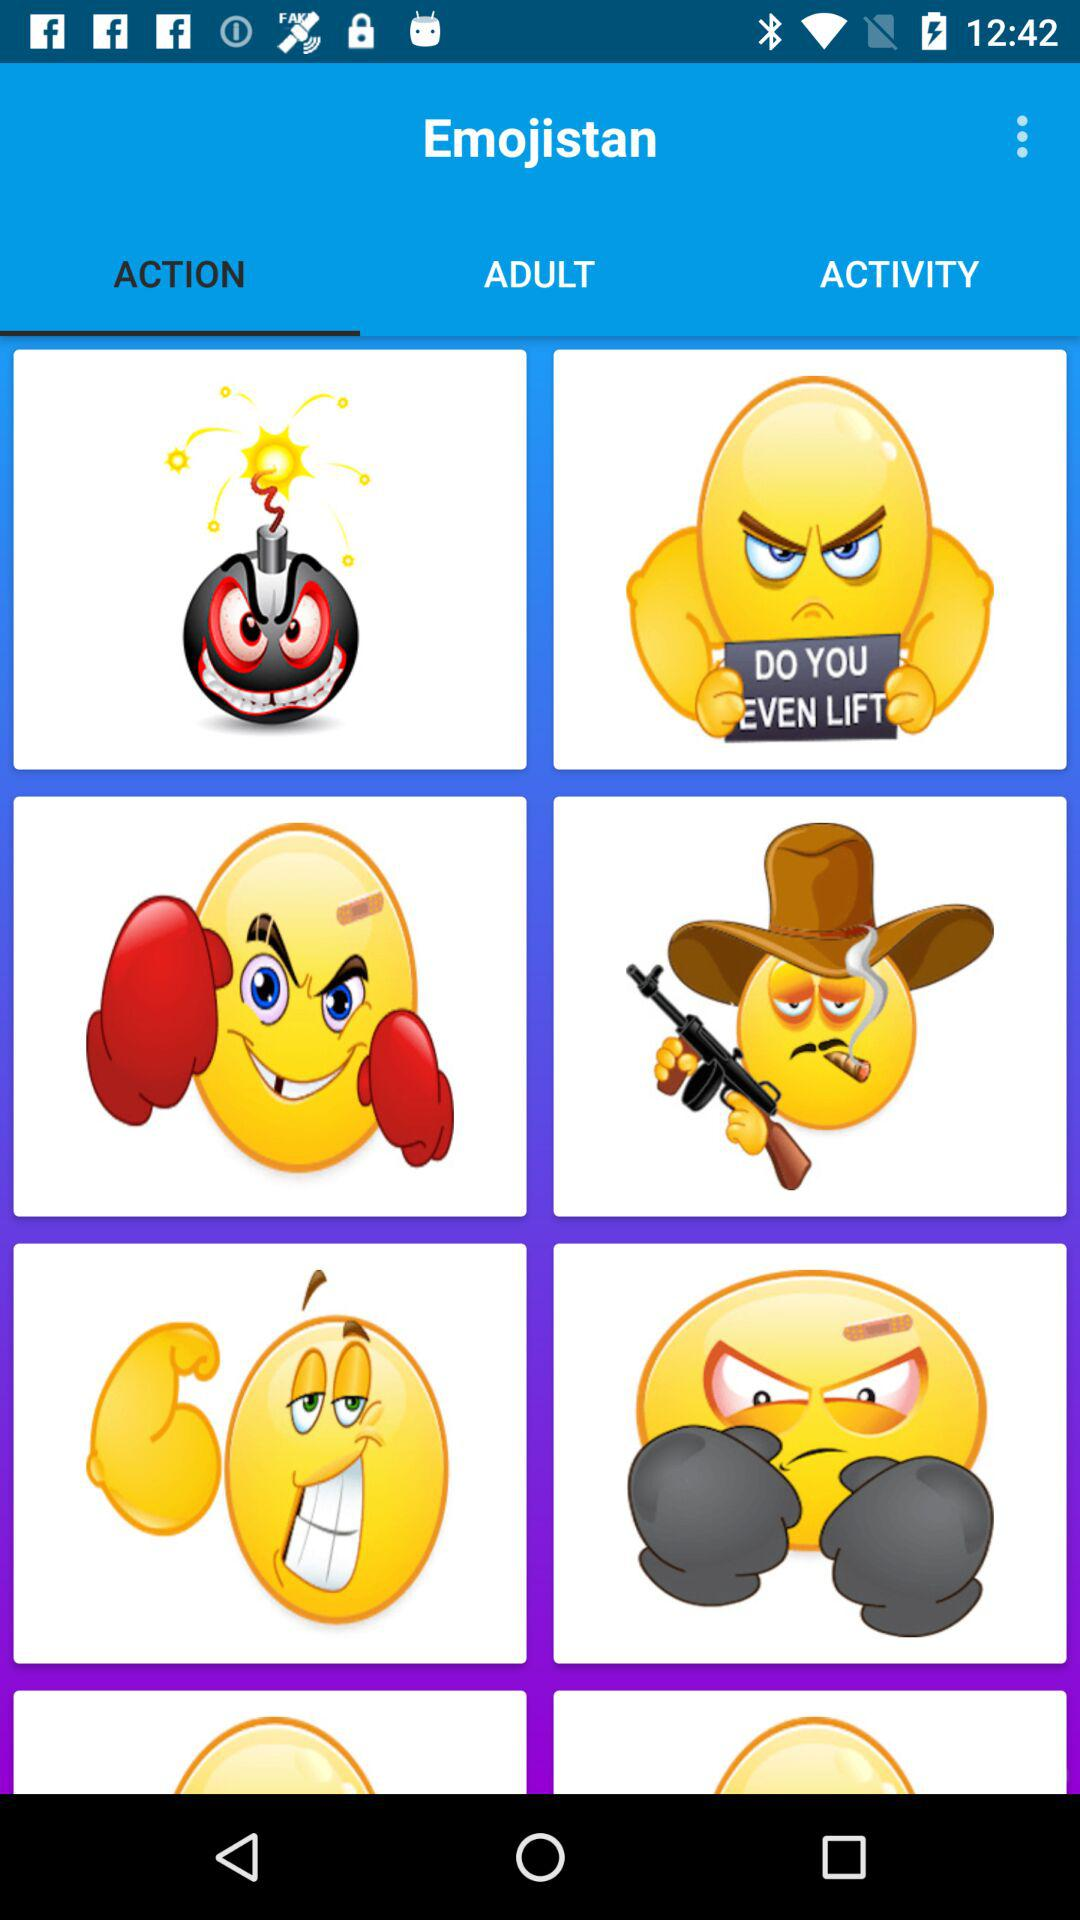Which tab is selected? The selected tab is "ACTION". 